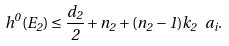<formula> <loc_0><loc_0><loc_500><loc_500>h ^ { 0 } ( E _ { 2 } ) \leq \frac { d _ { 2 } } { 2 } + n _ { 2 } + ( n _ { 2 } - 1 ) k _ { 2 } \ a _ { i } .</formula> 